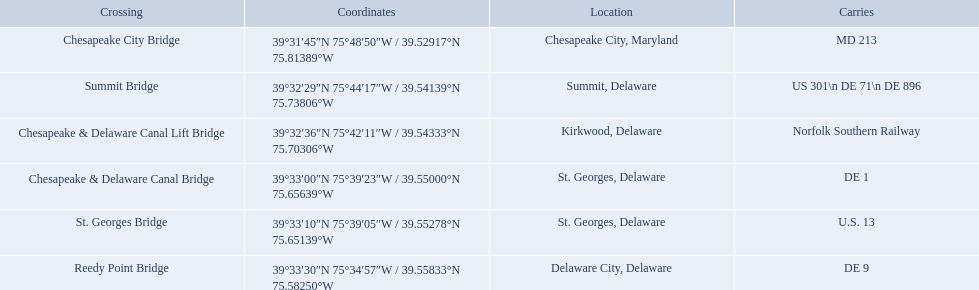What are the carries of the crossing located in summit, delaware? US 301\n DE 71\n DE 896. Based on the answer in the previous question, what is the name of the crossing? Summit Bridge. 